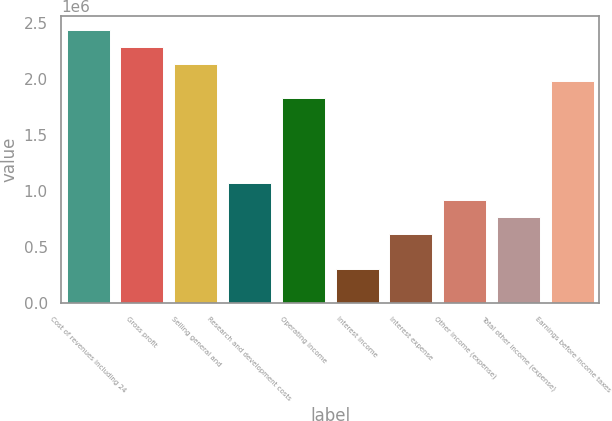<chart> <loc_0><loc_0><loc_500><loc_500><bar_chart><fcel>Cost of revenues including 24<fcel>Gross profit<fcel>Selling general and<fcel>Research and development costs<fcel>Operating income<fcel>Interest income<fcel>Interest expense<fcel>Other income (expense)<fcel>Total other income (expense)<fcel>Earnings before income taxes<nl><fcel>2.44028e+06<fcel>2.28776e+06<fcel>2.13524e+06<fcel>1.06762e+06<fcel>1.83021e+06<fcel>305036<fcel>610070<fcel>915105<fcel>762588<fcel>1.98273e+06<nl></chart> 